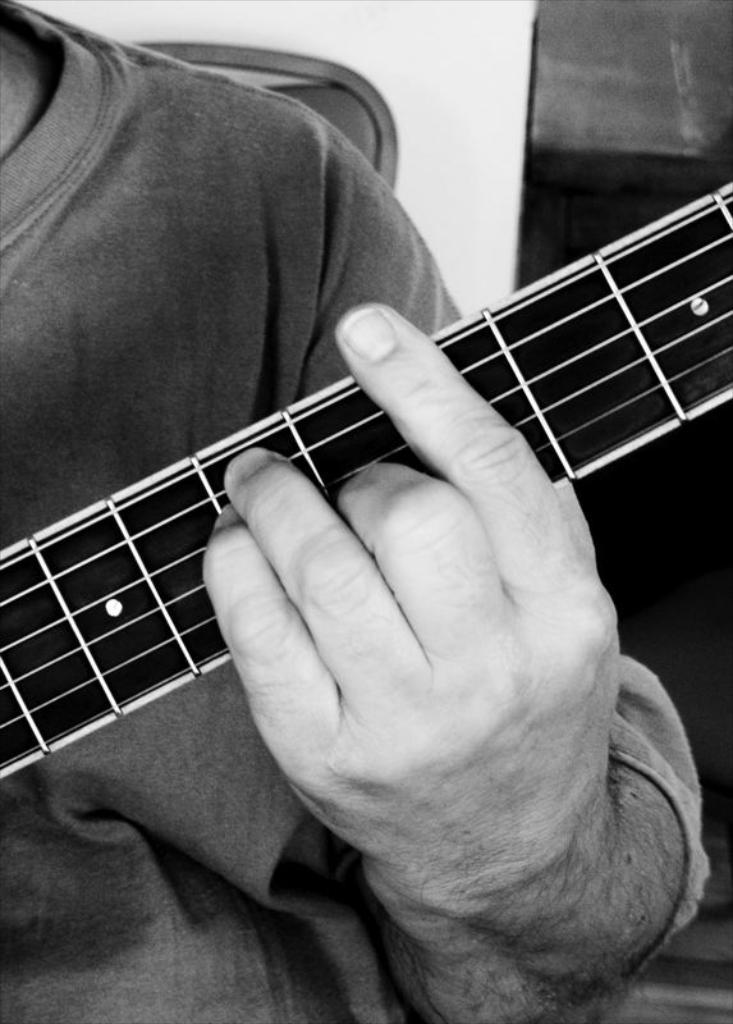What is the color scheme of the image? The image is black and white. Can you describe the main subject in the image? There is a man in the image. What is the man doing in the image? The man is playing a musical instrument. How does the man sort the skin in the image? There is no mention of sorting or skin in the image; the man is playing a musical instrument. 